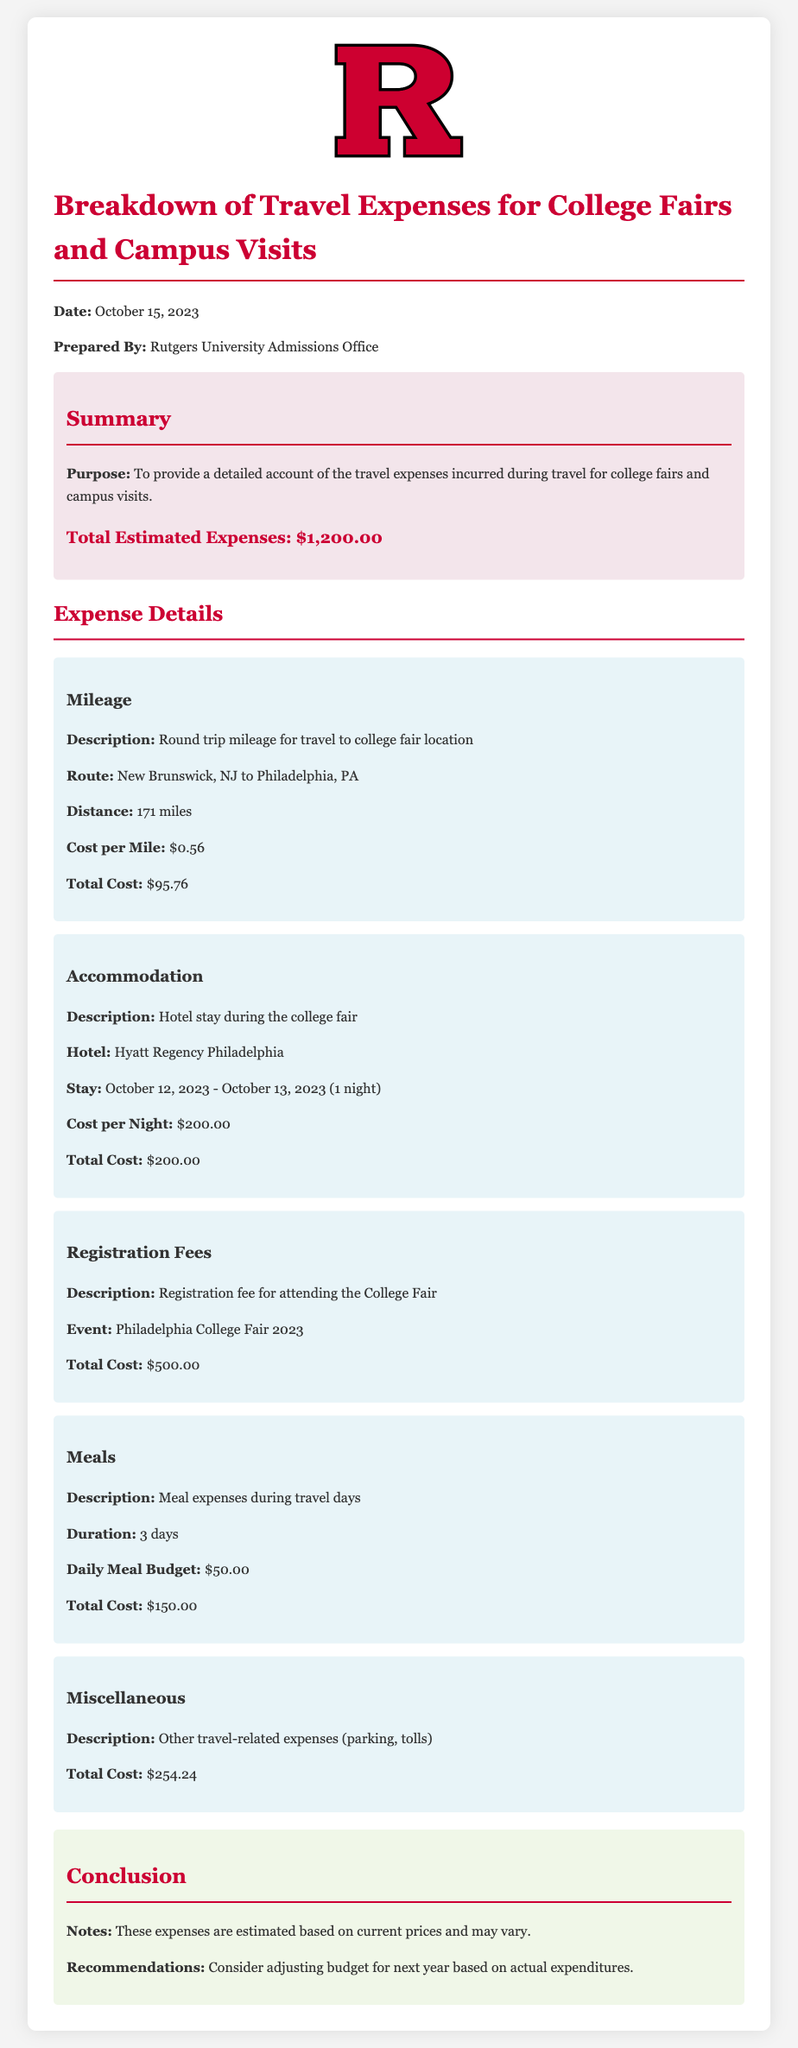What is the total estimated expenses? The total estimated expenses are detailed in the summary section of the document.
Answer: $1,200.00 What is the distance for the mileage? The distance for the mileage is specified in the expense details.
Answer: 171 miles What is the cost per night for accommodation? The cost per night for accommodation is listed under the accommodation section.
Answer: $200.00 What is the total cost for meals? The total cost for meals is found in the meals section of the report.
Answer: $150.00 What hotel was used for accommodation? The document specifies the hotel in the accommodation expense item.
Answer: Hyatt Regency Philadelphia What is the description of the miscellaneous expenses? The description of miscellaneous expenses is stated under the corresponding expense item.
Answer: Other travel-related expenses (parking, tolls) How many days were considered for meal expenses? The duration for which meal expenses were calculated is mentioned in the meals section.
Answer: 3 days What is the registration fee for attending the College Fair? The registration fee for the event is indicated in the registration fees section.
Answer: $500.00 What date was this report prepared? The date the report was prepared is shown prominently in the document.
Answer: October 15, 2023 